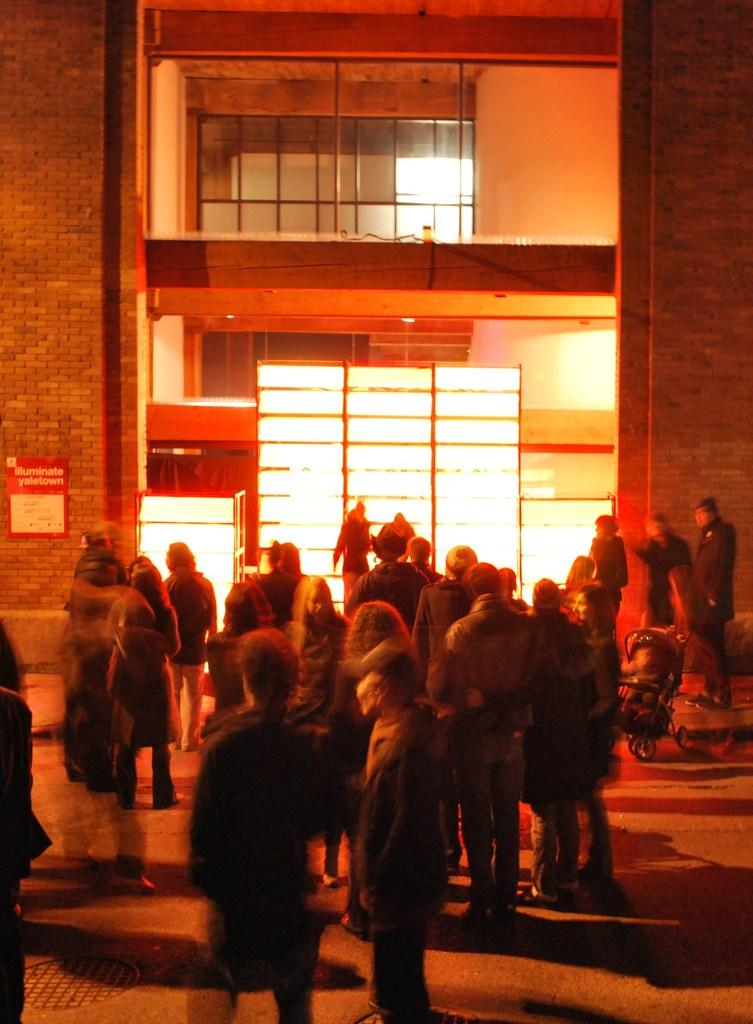What is happening in the image? There are persons standing in the image. What can be seen in the distance behind the persons? There is a building in the background of the image. Are there any additional features visible in the background? Yes, there are lights visible in the background of the image. What type of shelf can be seen in the image? There is no shelf present in the image. Can you hear the persons in the image crying? The image is silent, and there is no indication of any sounds or emotions, such as crying. 